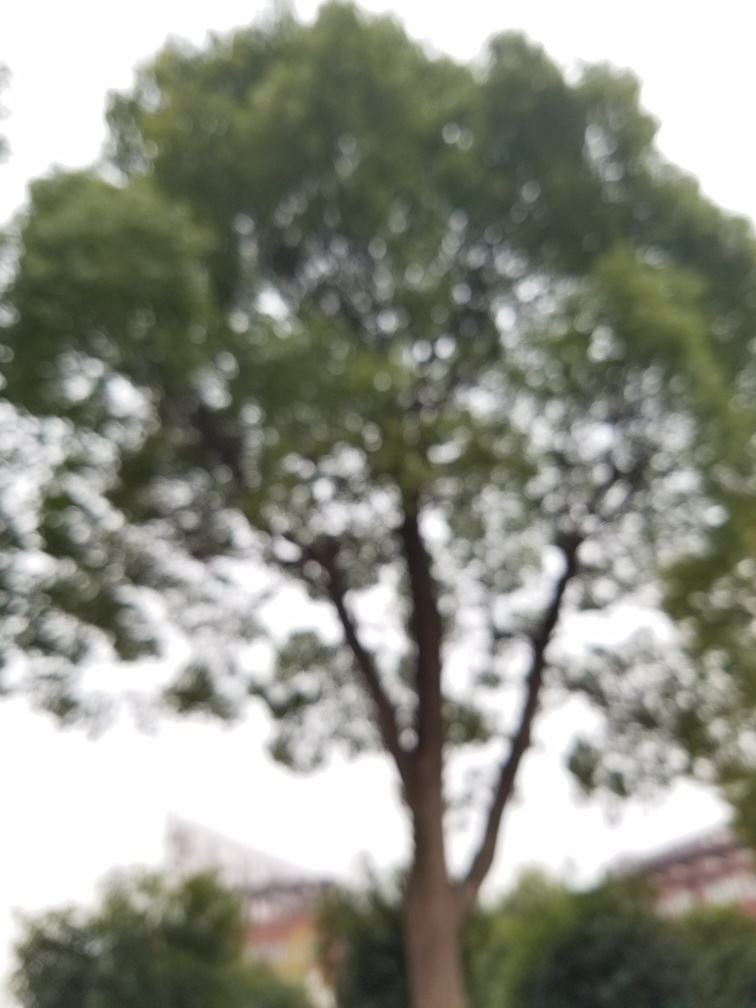Is there anything in particular about this tree that stands out despite the image being blurry? Despite the blurriness of the photo, the tree's silhouette is distinct against the light sky. Its shape suggests that it may be a mature tree with a full canopy of leaves. Such silhouettes can convey the strength or solitary character of the tree, potentially making it a focal point for viewers even when details are obscured. 